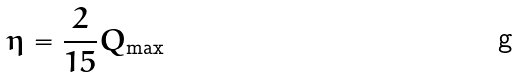<formula> <loc_0><loc_0><loc_500><loc_500>\eta = \frac { 2 } { 1 5 } Q _ { \max }</formula> 